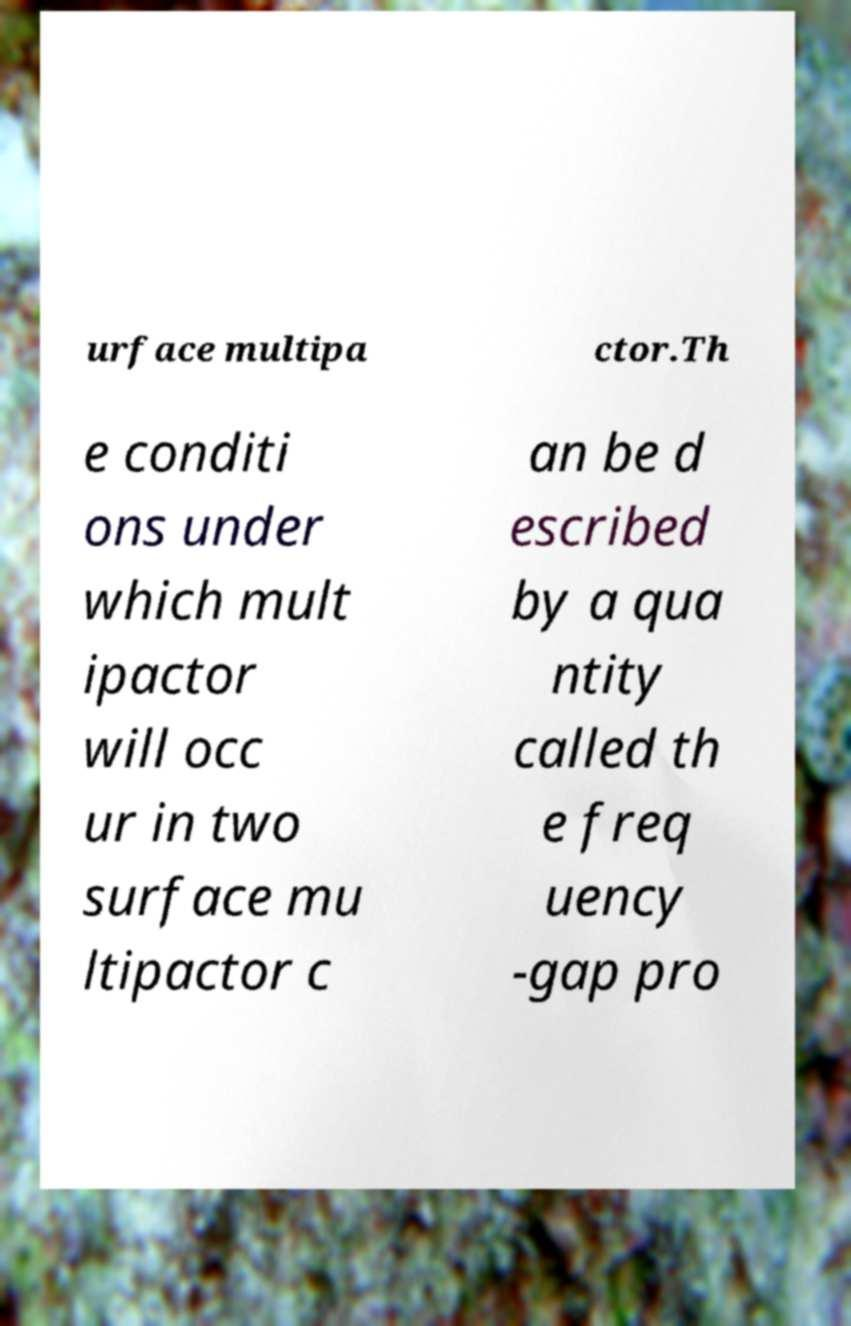Could you assist in decoding the text presented in this image and type it out clearly? urface multipa ctor.Th e conditi ons under which mult ipactor will occ ur in two surface mu ltipactor c an be d escribed by a qua ntity called th e freq uency -gap pro 